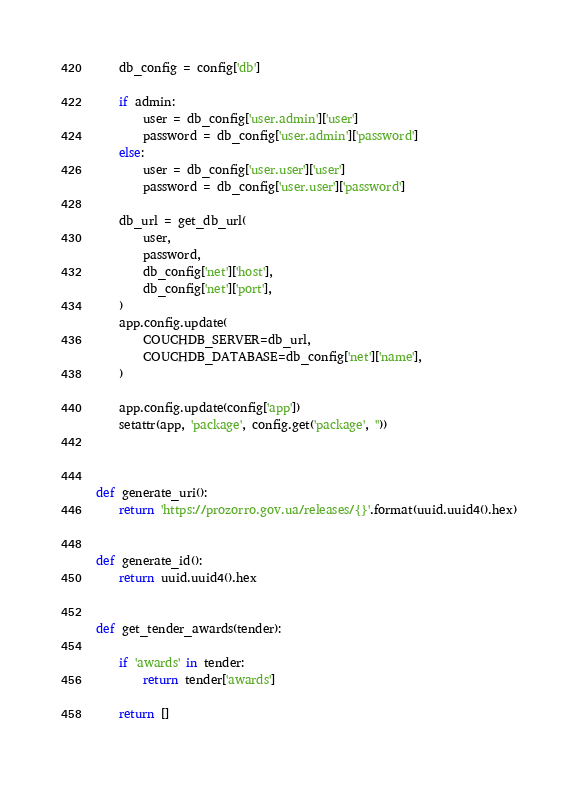Convert code to text. <code><loc_0><loc_0><loc_500><loc_500><_Python_>    db_config = config['db']

    if admin:
        user = db_config['user.admin']['user']
        password = db_config['user.admin']['password']
    else:
        user = db_config['user.user']['user']
        password = db_config['user.user']['password']

    db_url = get_db_url(
        user,
        password,
        db_config['net']['host'],
        db_config['net']['port'],
    )
    app.config.update(
        COUCHDB_SERVER=db_url,
        COUCHDB_DATABASE=db_config['net']['name'],
    )

    app.config.update(config['app'])
    setattr(app, 'package', config.get('package', ''))



def generate_uri():
    return 'https://prozorro.gov.ua/releases/{}'.format(uuid.uuid4().hex)


def generate_id():
    return uuid.uuid4().hex


def get_tender_awards(tender):

    if 'awards' in tender:
        return tender['awards']

    return []
</code> 